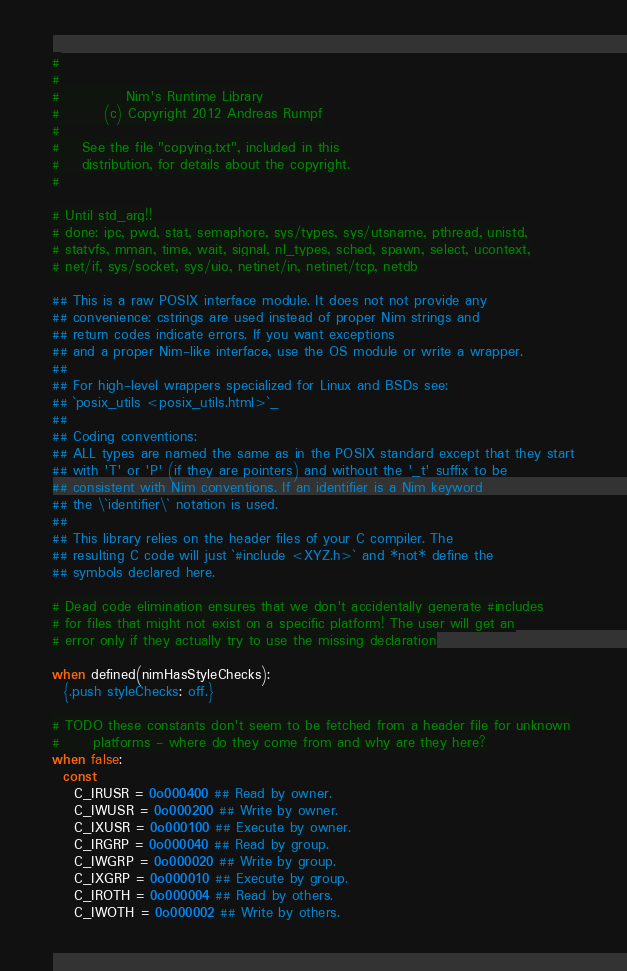<code> <loc_0><loc_0><loc_500><loc_500><_Nim_>#
#
#            Nim's Runtime Library
#        (c) Copyright 2012 Andreas Rumpf
#
#    See the file "copying.txt", included in this
#    distribution, for details about the copyright.
#

# Until std_arg!!
# done: ipc, pwd, stat, semaphore, sys/types, sys/utsname, pthread, unistd,
# statvfs, mman, time, wait, signal, nl_types, sched, spawn, select, ucontext,
# net/if, sys/socket, sys/uio, netinet/in, netinet/tcp, netdb

## This is a raw POSIX interface module. It does not not provide any
## convenience: cstrings are used instead of proper Nim strings and
## return codes indicate errors. If you want exceptions
## and a proper Nim-like interface, use the OS module or write a wrapper.
##
## For high-level wrappers specialized for Linux and BSDs see:
## `posix_utils <posix_utils.html>`_
##
## Coding conventions:
## ALL types are named the same as in the POSIX standard except that they start
## with 'T' or 'P' (if they are pointers) and without the '_t' suffix to be
## consistent with Nim conventions. If an identifier is a Nim keyword
## the \`identifier\` notation is used.
##
## This library relies on the header files of your C compiler. The
## resulting C code will just `#include <XYZ.h>` and *not* define the
## symbols declared here.

# Dead code elimination ensures that we don't accidentally generate #includes
# for files that might not exist on a specific platform! The user will get an
# error only if they actually try to use the missing declaration

when defined(nimHasStyleChecks):
  {.push styleChecks: off.}

# TODO these constants don't seem to be fetched from a header file for unknown
#      platforms - where do they come from and why are they here?
when false:
  const
    C_IRUSR = 0o000400 ## Read by owner.
    C_IWUSR = 0o000200 ## Write by owner.
    C_IXUSR = 0o000100 ## Execute by owner.
    C_IRGRP = 0o000040 ## Read by group.
    C_IWGRP = 0o000020 ## Write by group.
    C_IXGRP = 0o000010 ## Execute by group.
    C_IROTH = 0o000004 ## Read by others.
    C_IWOTH = 0o000002 ## Write by others.</code> 